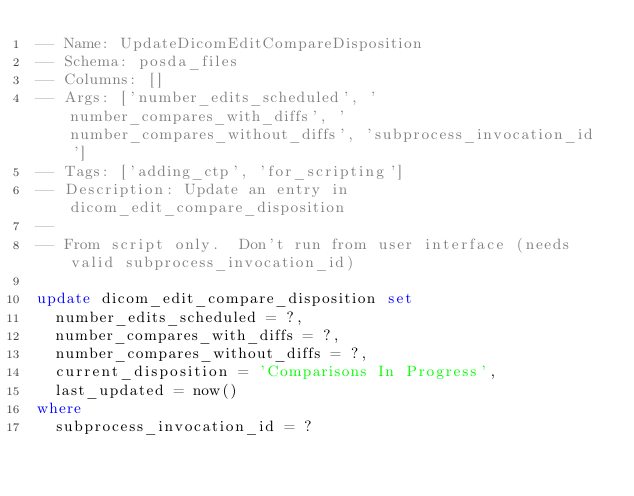Convert code to text. <code><loc_0><loc_0><loc_500><loc_500><_SQL_>-- Name: UpdateDicomEditCompareDisposition
-- Schema: posda_files
-- Columns: []
-- Args: ['number_edits_scheduled', 'number_compares_with_diffs', 'number_compares_without_diffs', 'subprocess_invocation_id']
-- Tags: ['adding_ctp', 'for_scripting']
-- Description: Update an entry in dicom_edit_compare_disposition
-- 
-- From script only.  Don't run from user interface (needs valid subprocess_invocation_id)

update dicom_edit_compare_disposition set
  number_edits_scheduled = ?,
  number_compares_with_diffs = ?,
  number_compares_without_diffs = ?,
  current_disposition = 'Comparisons In Progress',
  last_updated = now()
where
  subprocess_invocation_id = ?
</code> 